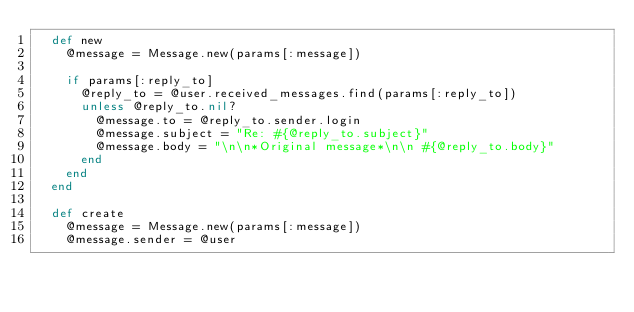<code> <loc_0><loc_0><loc_500><loc_500><_Ruby_>  def new
    @message = Message.new(params[:message])

    if params[:reply_to]
      @reply_to = @user.received_messages.find(params[:reply_to])
      unless @reply_to.nil?
        @message.to = @reply_to.sender.login
        @message.subject = "Re: #{@reply_to.subject}"
        @message.body = "\n\n*Original message*\n\n #{@reply_to.body}"
      end
    end
  end
  
  def create
    @message = Message.new(params[:message])
    @message.sender = @user</code> 